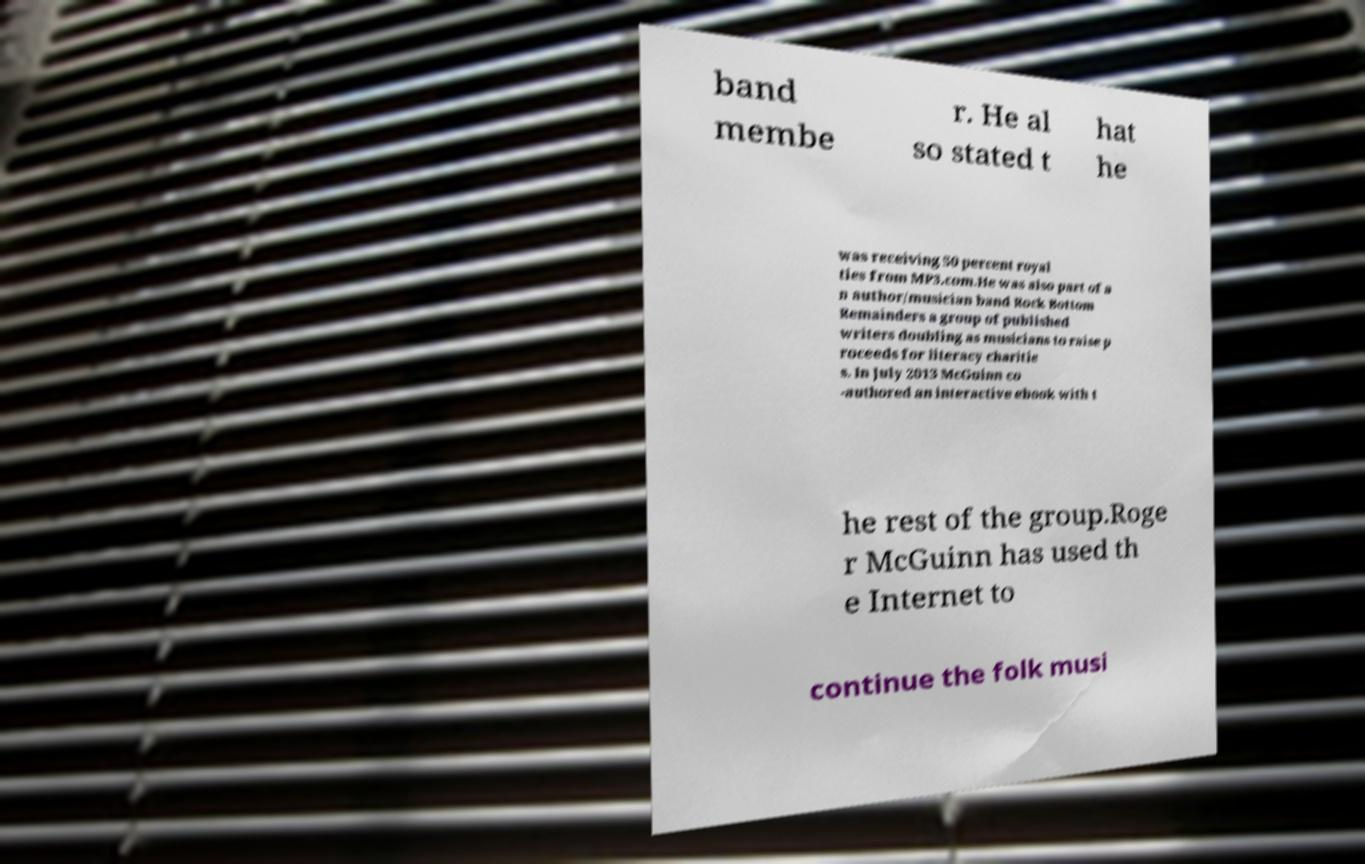Please identify and transcribe the text found in this image. band membe r. He al so stated t hat he was receiving 50 percent royal ties from MP3.com.He was also part of a n author/musician band Rock Bottom Remainders a group of published writers doubling as musicians to raise p roceeds for literacy charitie s. In July 2013 McGuinn co -authored an interactive ebook with t he rest of the group.Roge r McGuinn has used th e Internet to continue the folk musi 